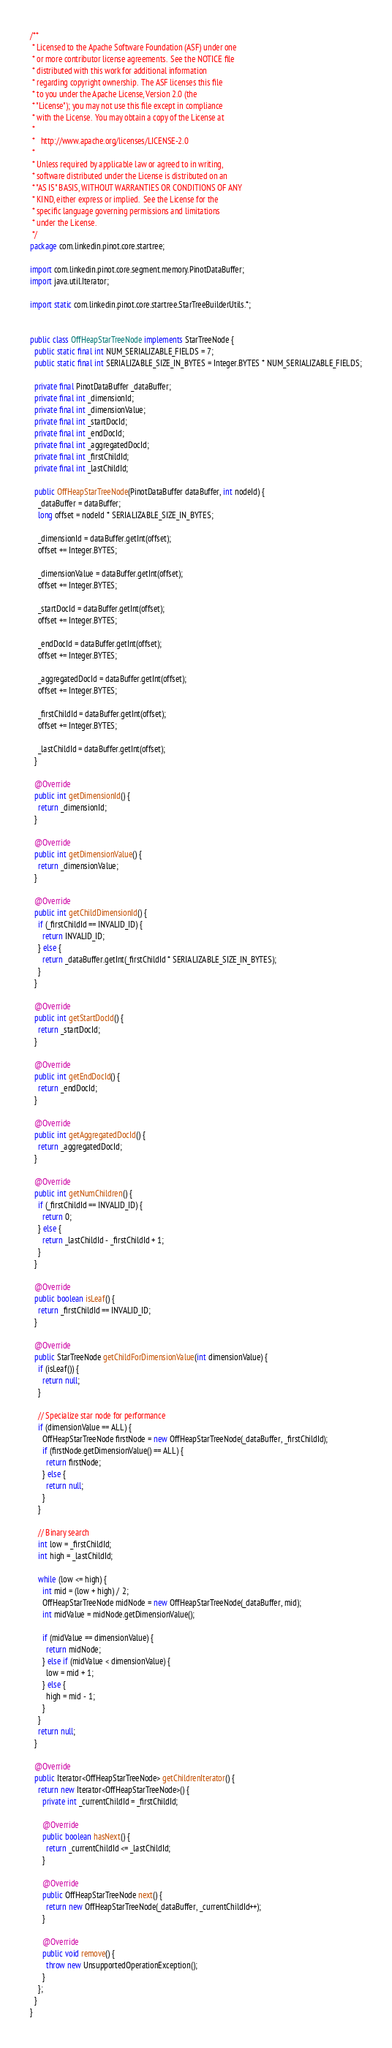<code> <loc_0><loc_0><loc_500><loc_500><_Java_>/**
 * Licensed to the Apache Software Foundation (ASF) under one
 * or more contributor license agreements.  See the NOTICE file
 * distributed with this work for additional information
 * regarding copyright ownership.  The ASF licenses this file
 * to you under the Apache License, Version 2.0 (the
 * "License"); you may not use this file except in compliance
 * with the License.  You may obtain a copy of the License at
 *
 *   http://www.apache.org/licenses/LICENSE-2.0
 *
 * Unless required by applicable law or agreed to in writing,
 * software distributed under the License is distributed on an
 * "AS IS" BASIS, WITHOUT WARRANTIES OR CONDITIONS OF ANY
 * KIND, either express or implied.  See the License for the
 * specific language governing permissions and limitations
 * under the License.
 */
package com.linkedin.pinot.core.startree;

import com.linkedin.pinot.core.segment.memory.PinotDataBuffer;
import java.util.Iterator;

import static com.linkedin.pinot.core.startree.StarTreeBuilderUtils.*;


public class OffHeapStarTreeNode implements StarTreeNode {
  public static final int NUM_SERIALIZABLE_FIELDS = 7;
  public static final int SERIALIZABLE_SIZE_IN_BYTES = Integer.BYTES * NUM_SERIALIZABLE_FIELDS;

  private final PinotDataBuffer _dataBuffer;
  private final int _dimensionId;
  private final int _dimensionValue;
  private final int _startDocId;
  private final int _endDocId;
  private final int _aggregatedDocId;
  private final int _firstChildId;
  private final int _lastChildId;

  public OffHeapStarTreeNode(PinotDataBuffer dataBuffer, int nodeId) {
    _dataBuffer = dataBuffer;
    long offset = nodeId * SERIALIZABLE_SIZE_IN_BYTES;

    _dimensionId = dataBuffer.getInt(offset);
    offset += Integer.BYTES;

    _dimensionValue = dataBuffer.getInt(offset);
    offset += Integer.BYTES;

    _startDocId = dataBuffer.getInt(offset);
    offset += Integer.BYTES;

    _endDocId = dataBuffer.getInt(offset);
    offset += Integer.BYTES;

    _aggregatedDocId = dataBuffer.getInt(offset);
    offset += Integer.BYTES;

    _firstChildId = dataBuffer.getInt(offset);
    offset += Integer.BYTES;

    _lastChildId = dataBuffer.getInt(offset);
  }

  @Override
  public int getDimensionId() {
    return _dimensionId;
  }

  @Override
  public int getDimensionValue() {
    return _dimensionValue;
  }

  @Override
  public int getChildDimensionId() {
    if (_firstChildId == INVALID_ID) {
      return INVALID_ID;
    } else {
      return _dataBuffer.getInt(_firstChildId * SERIALIZABLE_SIZE_IN_BYTES);
    }
  }

  @Override
  public int getStartDocId() {
    return _startDocId;
  }

  @Override
  public int getEndDocId() {
    return _endDocId;
  }

  @Override
  public int getAggregatedDocId() {
    return _aggregatedDocId;
  }

  @Override
  public int getNumChildren() {
    if (_firstChildId == INVALID_ID) {
      return 0;
    } else {
      return _lastChildId - _firstChildId + 1;
    }
  }

  @Override
  public boolean isLeaf() {
    return _firstChildId == INVALID_ID;
  }

  @Override
  public StarTreeNode getChildForDimensionValue(int dimensionValue) {
    if (isLeaf()) {
      return null;
    }

    // Specialize star node for performance
    if (dimensionValue == ALL) {
      OffHeapStarTreeNode firstNode = new OffHeapStarTreeNode(_dataBuffer, _firstChildId);
      if (firstNode.getDimensionValue() == ALL) {
        return firstNode;
      } else {
        return null;
      }
    }

    // Binary search
    int low = _firstChildId;
    int high = _lastChildId;

    while (low <= high) {
      int mid = (low + high) / 2;
      OffHeapStarTreeNode midNode = new OffHeapStarTreeNode(_dataBuffer, mid);
      int midValue = midNode.getDimensionValue();

      if (midValue == dimensionValue) {
        return midNode;
      } else if (midValue < dimensionValue) {
        low = mid + 1;
      } else {
        high = mid - 1;
      }
    }
    return null;
  }

  @Override
  public Iterator<OffHeapStarTreeNode> getChildrenIterator() {
    return new Iterator<OffHeapStarTreeNode>() {
      private int _currentChildId = _firstChildId;

      @Override
      public boolean hasNext() {
        return _currentChildId <= _lastChildId;
      }

      @Override
      public OffHeapStarTreeNode next() {
        return new OffHeapStarTreeNode(_dataBuffer, _currentChildId++);
      }

      @Override
      public void remove() {
        throw new UnsupportedOperationException();
      }
    };
  }
}
</code> 